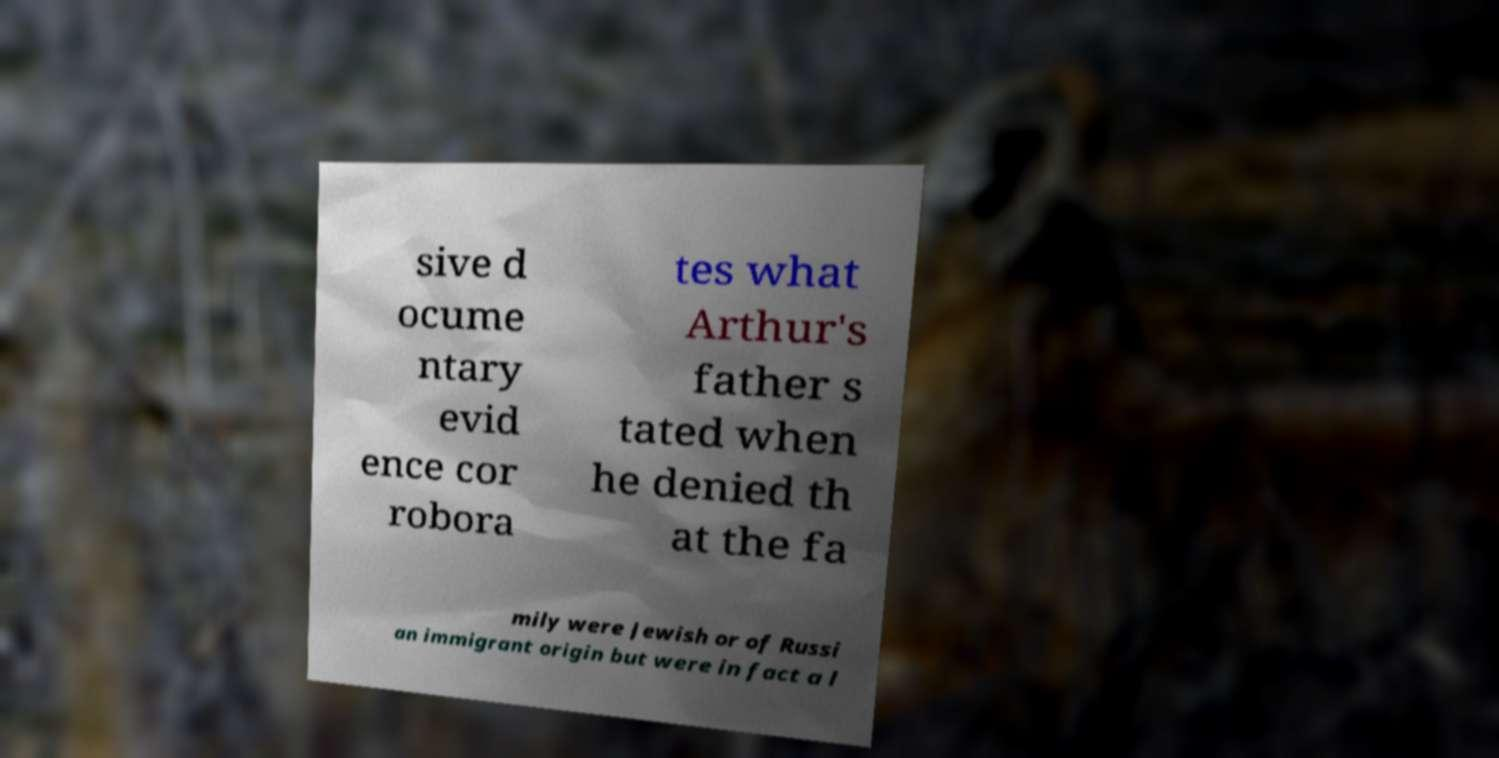For documentation purposes, I need the text within this image transcribed. Could you provide that? sive d ocume ntary evid ence cor robora tes what Arthur's father s tated when he denied th at the fa mily were Jewish or of Russi an immigrant origin but were in fact a l 